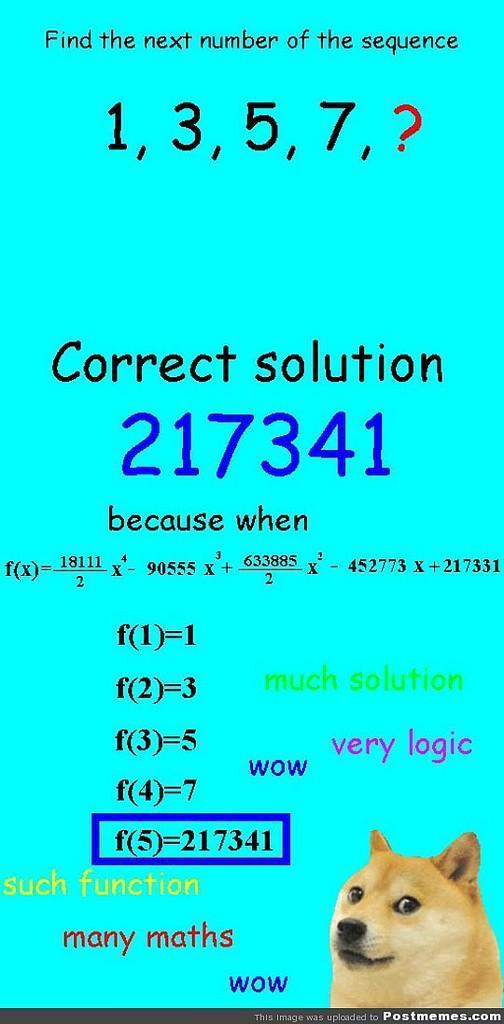Please provide a concise description of this image. In this image I can see a dog which is cream, brown and black in color and I can see something is written with black, blue and green color on the blue colored background. 